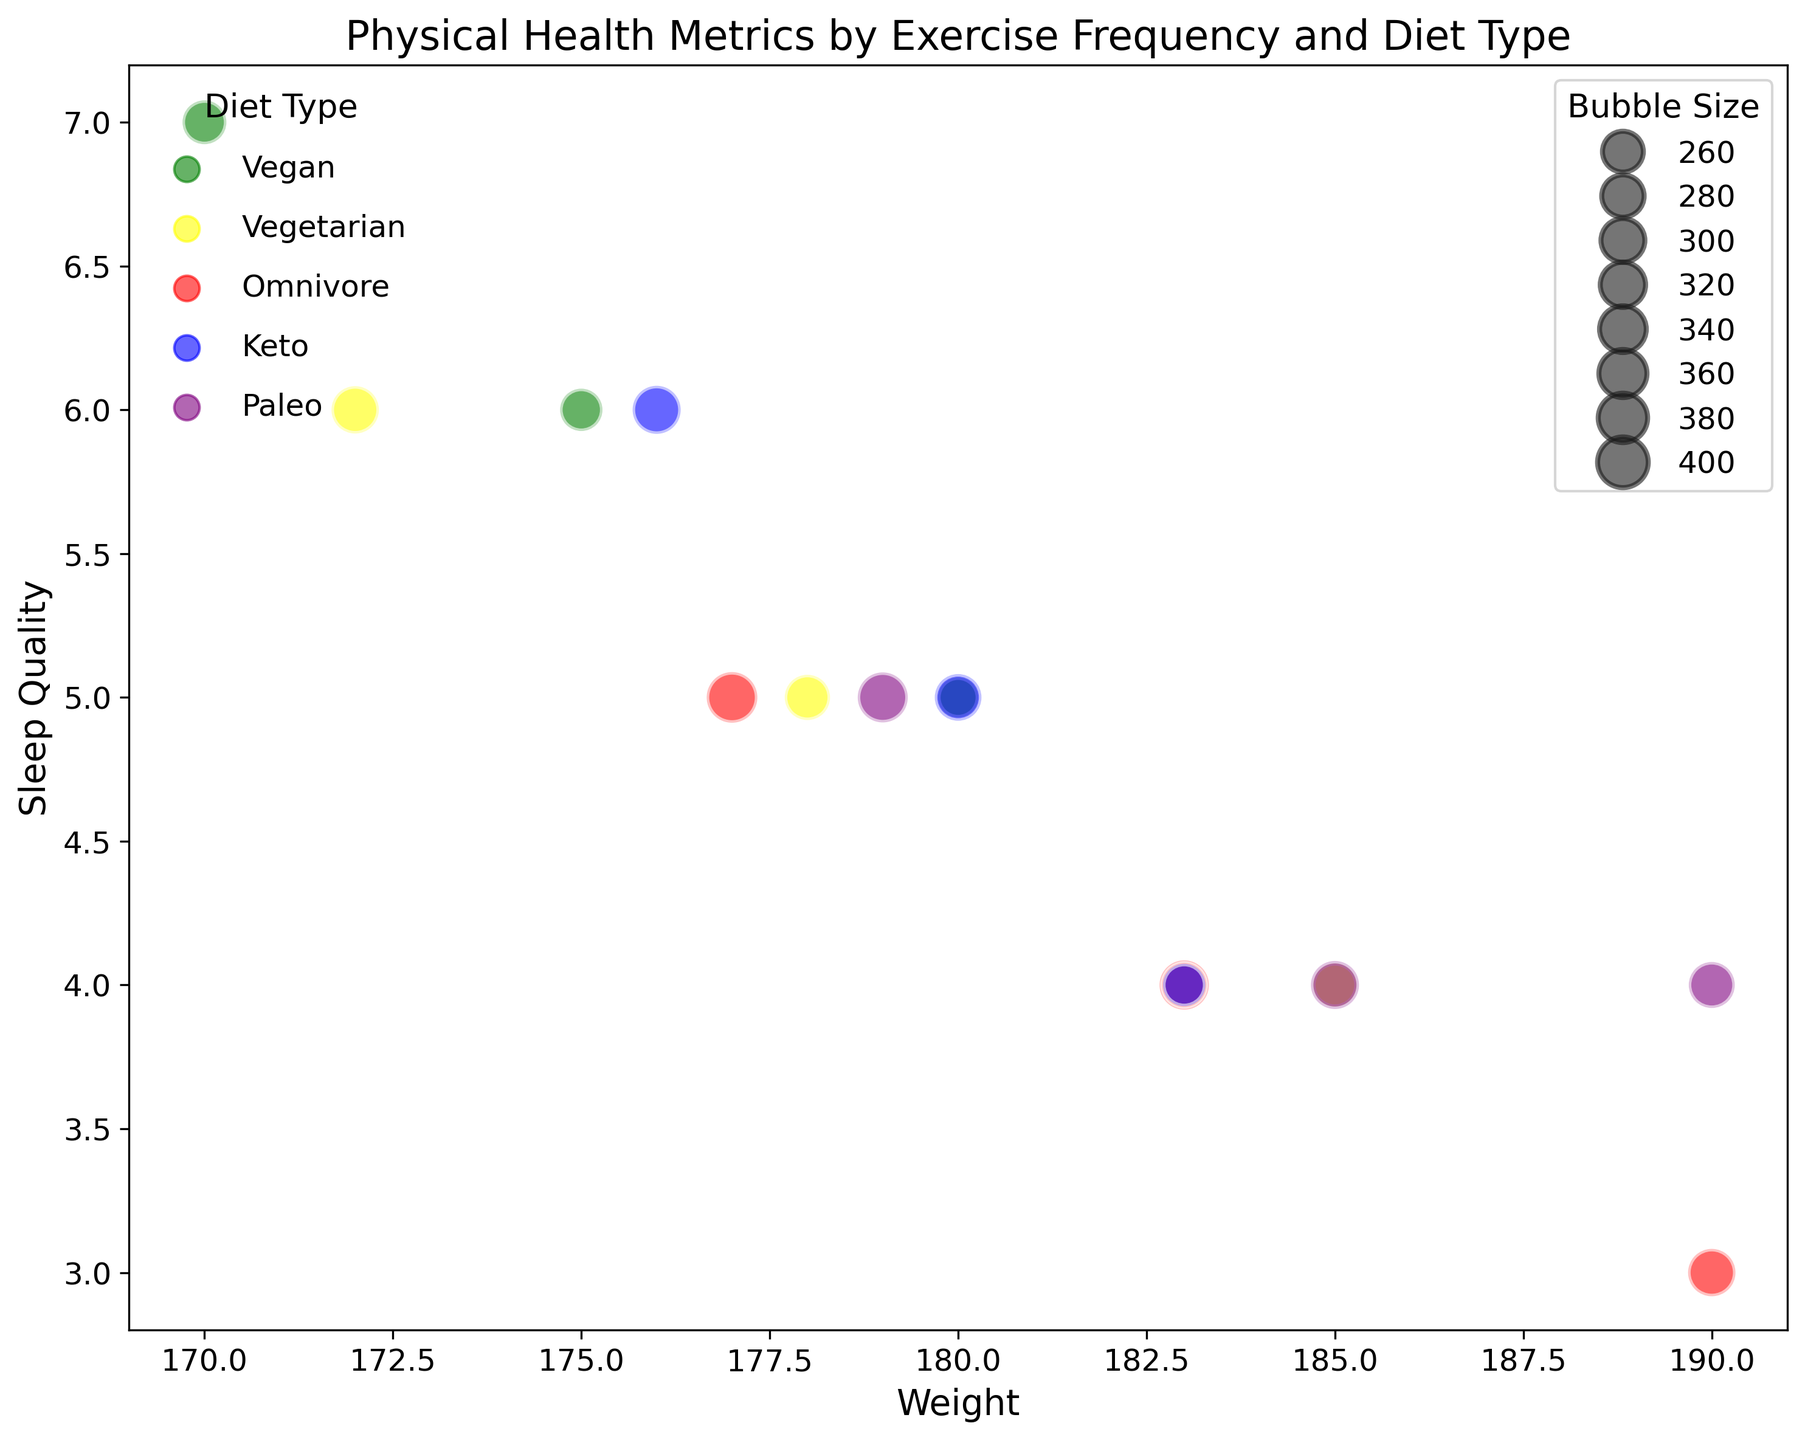What's the average sleep quality for people on a vegan diet? The data shows three points for the Vegan diet with sleep quality values of 5, 6, and 7. Summing these values gives 18, and the average is 18 divided by 3.
Answer: 6 Which group has the lowest weight among those with high exercise frequency? The high exercise frequency group has three types of diets: Vegan (170), Vegetarian (172), and Omnivore (177). The lowest weight is 170.
Answer: Vegan Which diet type in the low exercise frequency group has the highest bubble size? The bubble sizes for the low exercise frequency group are Vegan (25), Vegetarian (30), Omnivore (35), Keto (28), and Paleo (33). The highest bubble size is 35.
Answer: Omnivore Compare the sleep quality of those on a moderate exercise frequency with a vegetarian diet versus a keto diet. Which is higher? The sleep quality for the moderate frequency with a vegetarian diet is 5, and for the keto diet is also 5. Since they are the same, neither is higher.
Answer: Equal What is the difference in weight between those on a high exercise frequency with a vegan diet and a moderate exercise frequency with an omnivore diet? The weight for a high exercise frequency with a vegan diet is 170 and for a moderate exercise frequency with an omnivore diet is 183. The difference is 183 - 170.
Answer: 13 Which diet type has the highest sleep quality overall? Vegan diet types have sleep quality values of 5, 6, and 7. Other diet types have maximum values lower than 7. Thus, Vegan has the highest sleep quality with the value 7.
Answer: Vegan Among those who follow a Paleo diet, which group has the highest bubble size? The bubble sizes for Paleo diets are Low (33), Moderate (36), and High (39). The highest bubble size is 39.
Answer: High What's the average blood pressure for people with low exercise frequency? The blood pressures for the low exercise frequency are 130/85, 135/88, 140/90, and 135/88. Averaging the systolic values (130, 135, 140, 135) gives 135, and averaging the diastolic values (85, 88, 90, 88) gives 87.75.
Answer: 135/87.75 What is the commonality in sleep quality among those on a Vegetarian diet regardless of exercise frequency? The observed sleep quality for Vegetarian diet types are 4 (Low), 5 (Moderate), and 6 (High). The commonality in sleep quality is not present as all values are different.
Answer: None How would you describe the relationship between weight and sleep quality for participants with high exercise frequency and a Vegan diet? The point for high exercise frequency and a Vegan diet shows a weight of 170 and sleep quality of 7. As per this data, higher exercise frequency with a Vegan diet corresponds to higher sleep quality and lower weight.
Answer: Higher sleep quality and lower weight 